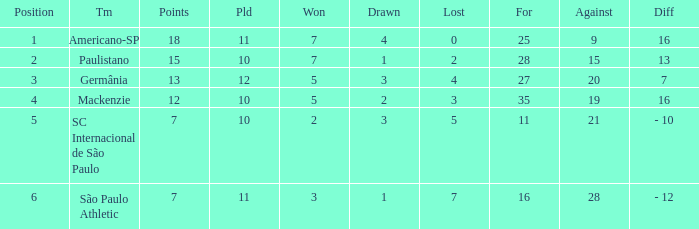Name the most for when difference is 7 27.0. 